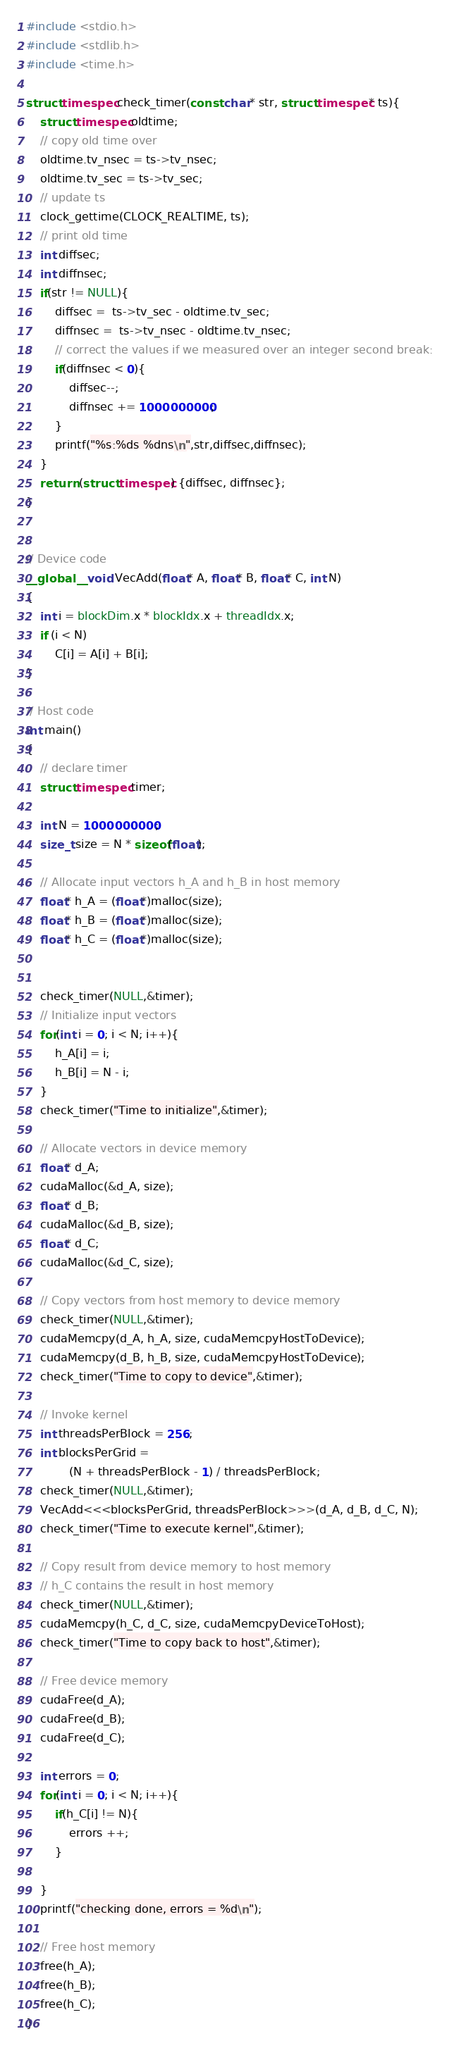Convert code to text. <code><loc_0><loc_0><loc_500><loc_500><_Cuda_>#include <stdio.h>
#include <stdlib.h>
#include <time.h>

struct timespec check_timer(const char* str, struct timespec* ts){
	struct timespec oldtime;
	// copy old time over
	oldtime.tv_nsec = ts->tv_nsec;
	oldtime.tv_sec = ts->tv_sec;
	// update ts
	clock_gettime(CLOCK_REALTIME, ts);
	// print old time
	int diffsec;
	int diffnsec;
	if(str != NULL){
		diffsec =  ts->tv_sec - oldtime.tv_sec;
		diffnsec =  ts->tv_nsec - oldtime.tv_nsec;
		// correct the values if we measured over an integer second break:
		if(diffnsec < 0){
			diffsec--;
			diffnsec += 1000000000;
		}
		printf("%s:%ds %dns\n",str,diffsec,diffnsec);
	}
	return (struct timespec) {diffsec, diffnsec};
}
 

// Device code
__global__ void VecAdd(float* A, float* B, float* C, int N)
{
    int i = blockDim.x * blockIdx.x + threadIdx.x;
    if (i < N)
        C[i] = A[i] + B[i];
}
            
// Host code
int main()
{
	// declare timer
	struct timespec timer;

    int N = 1000000000;
    size_t size = N * sizeof(float);

    // Allocate input vectors h_A and h_B in host memory
    float* h_A = (float*)malloc(size);
    float* h_B = (float*)malloc(size);
    float* h_C = (float*)malloc(size);


	check_timer(NULL,&timer);
    // Initialize input vectors
    for(int i = 0; i < N; i++){
    	h_A[i] = i;
    	h_B[i] = N - i;
    }
	check_timer("Time to initialize",&timer);

    // Allocate vectors in device memory
    float* d_A;
    cudaMalloc(&d_A, size);
    float* d_B;
    cudaMalloc(&d_B, size);
    float* d_C;
    cudaMalloc(&d_C, size);

    // Copy vectors from host memory to device memory
	check_timer(NULL,&timer);
    cudaMemcpy(d_A, h_A, size, cudaMemcpyHostToDevice);
    cudaMemcpy(d_B, h_B, size, cudaMemcpyHostToDevice);
	check_timer("Time to copy to device",&timer);

    // Invoke kernel
    int threadsPerBlock = 256;
    int blocksPerGrid =
            (N + threadsPerBlock - 1) / threadsPerBlock;
	check_timer(NULL,&timer);
    VecAdd<<<blocksPerGrid, threadsPerBlock>>>(d_A, d_B, d_C, N);
	check_timer("Time to execute kernel",&timer);

    // Copy result from device memory to host memory
    // h_C contains the result in host memory
	check_timer(NULL,&timer);
    cudaMemcpy(h_C, d_C, size, cudaMemcpyDeviceToHost);
	check_timer("Time to copy back to host",&timer);

    // Free device memory
    cudaFree(d_A);
    cudaFree(d_B);
    cudaFree(d_C);

    int errors = 0;
    for(int i = 0; i < N; i++){
    	if(h_C[i] != N){
    		errors ++;
    	}

    }
    printf("checking done, errors = %d\n");

    // Free host memory
    free(h_A);
    free(h_B);
    free(h_C);
}</code> 